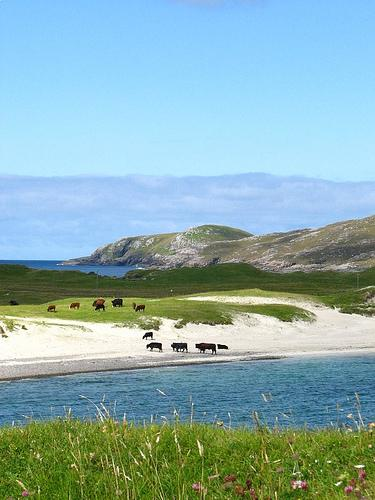How would they transport the cattle to the nearest patch of grass? Please explain your reasoning. boat. A boat is needed to cross the water. 